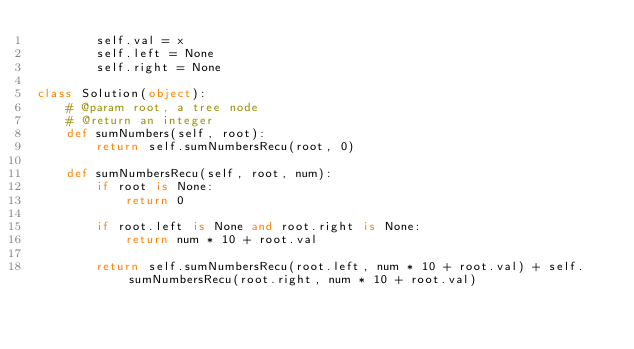<code> <loc_0><loc_0><loc_500><loc_500><_Python_>        self.val = x
        self.left = None
        self.right = None

class Solution(object):
    # @param root, a tree node
    # @return an integer
    def sumNumbers(self, root):
        return self.sumNumbersRecu(root, 0)

    def sumNumbersRecu(self, root, num):
        if root is None:
            return 0

        if root.left is None and root.right is None:
            return num * 10 + root.val

        return self.sumNumbersRecu(root.left, num * 10 + root.val) + self.sumNumbersRecu(root.right, num * 10 + root.val)

</code> 